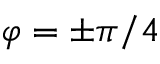<formula> <loc_0><loc_0><loc_500><loc_500>\varphi = \pm \pi / 4</formula> 